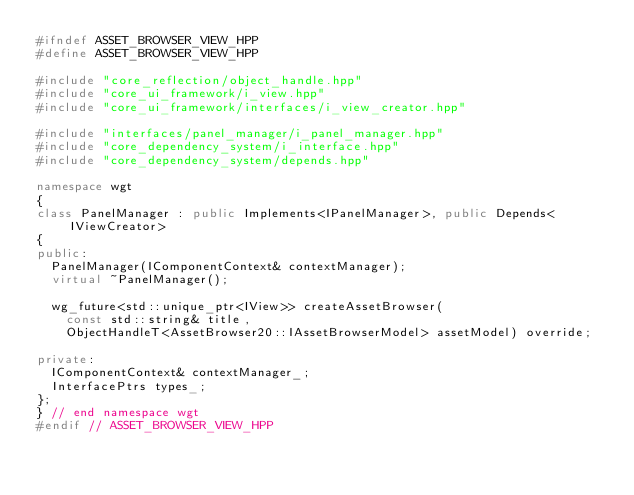Convert code to text. <code><loc_0><loc_0><loc_500><loc_500><_C++_>#ifndef ASSET_BROWSER_VIEW_HPP
#define ASSET_BROWSER_VIEW_HPP

#include "core_reflection/object_handle.hpp"
#include "core_ui_framework/i_view.hpp"
#include "core_ui_framework/interfaces/i_view_creator.hpp"

#include "interfaces/panel_manager/i_panel_manager.hpp"
#include "core_dependency_system/i_interface.hpp"
#include "core_dependency_system/depends.hpp"

namespace wgt
{
class PanelManager : public Implements<IPanelManager>, public Depends<IViewCreator>
{
public:
	PanelManager(IComponentContext& contextManager);
	virtual ~PanelManager();

	wg_future<std::unique_ptr<IView>> createAssetBrowser(
		const std::string& title,
		ObjectHandleT<AssetBrowser20::IAssetBrowserModel> assetModel) override;

private:
	IComponentContext& contextManager_;
	InterfacePtrs types_;
};
} // end namespace wgt
#endif // ASSET_BROWSER_VIEW_HPP
</code> 